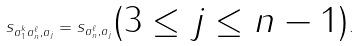Convert formula to latex. <formula><loc_0><loc_0><loc_500><loc_500>s _ { a _ { 1 } ^ { k } a _ { n } ^ { \ell } , a _ { j } } = s _ { a _ { n } ^ { \ell } , a _ { j } } \text {($3\leq j \leq n-1$)} .</formula> 